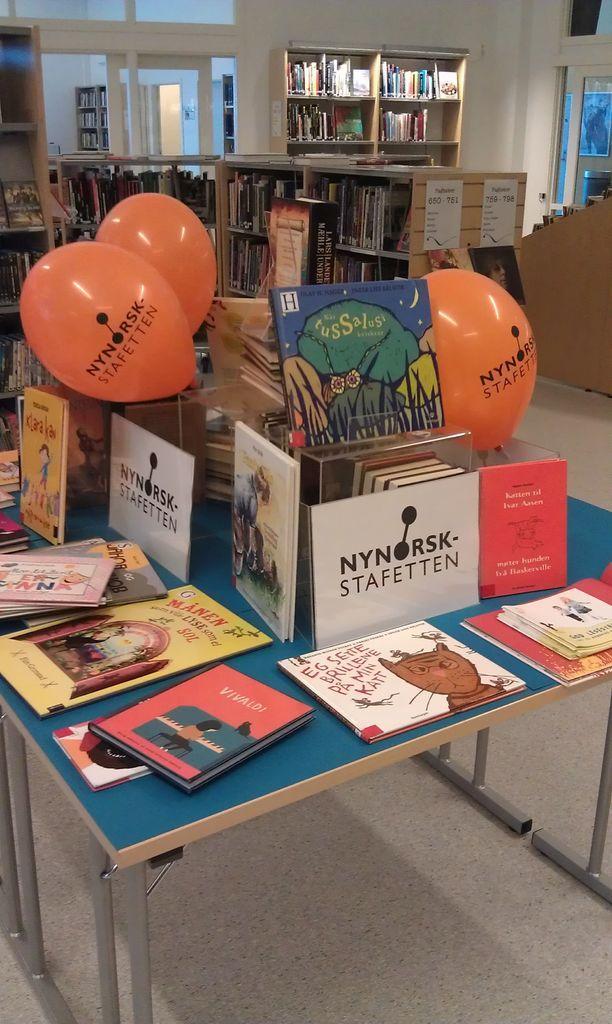In one or two sentences, can you explain what this image depicts? The picture is a bookstore. In the foreground there is a table. On the table there are books, balloons. In the background there are bookshelves. On the top right there is a window. On the top left there is a door. 